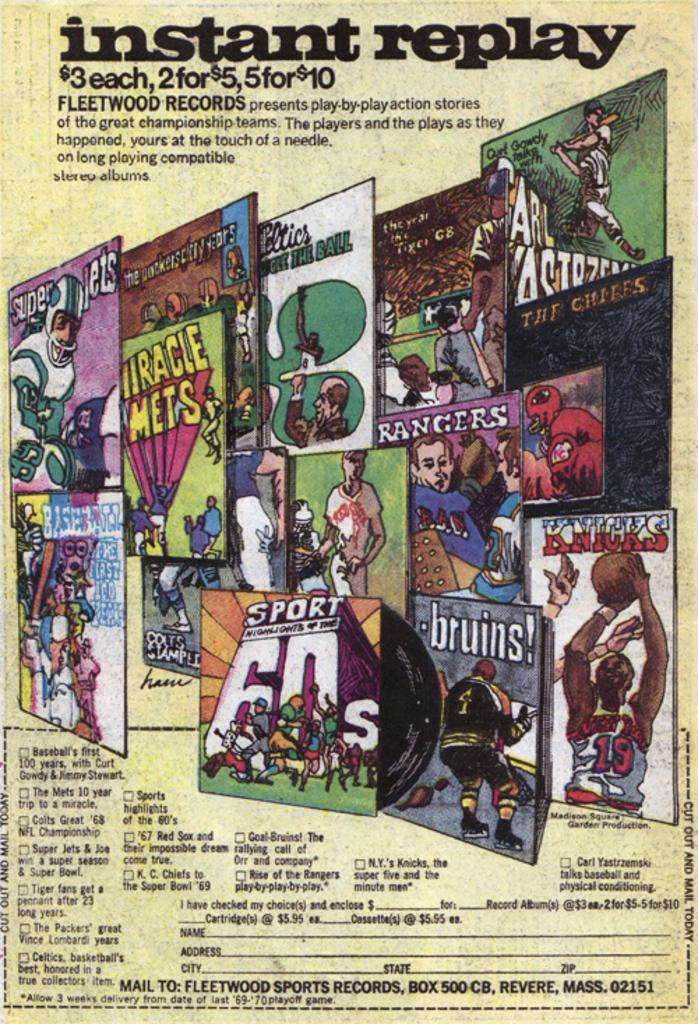Provide a one-sentence caption for the provided image. a poster that has instant replay written on it. 